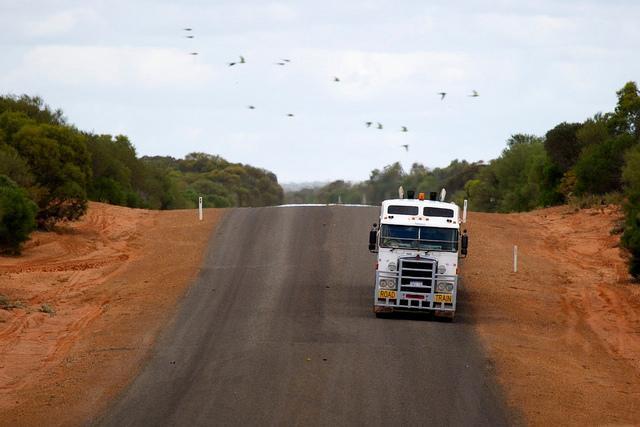How many people in this picture have bananas?
Give a very brief answer. 0. 